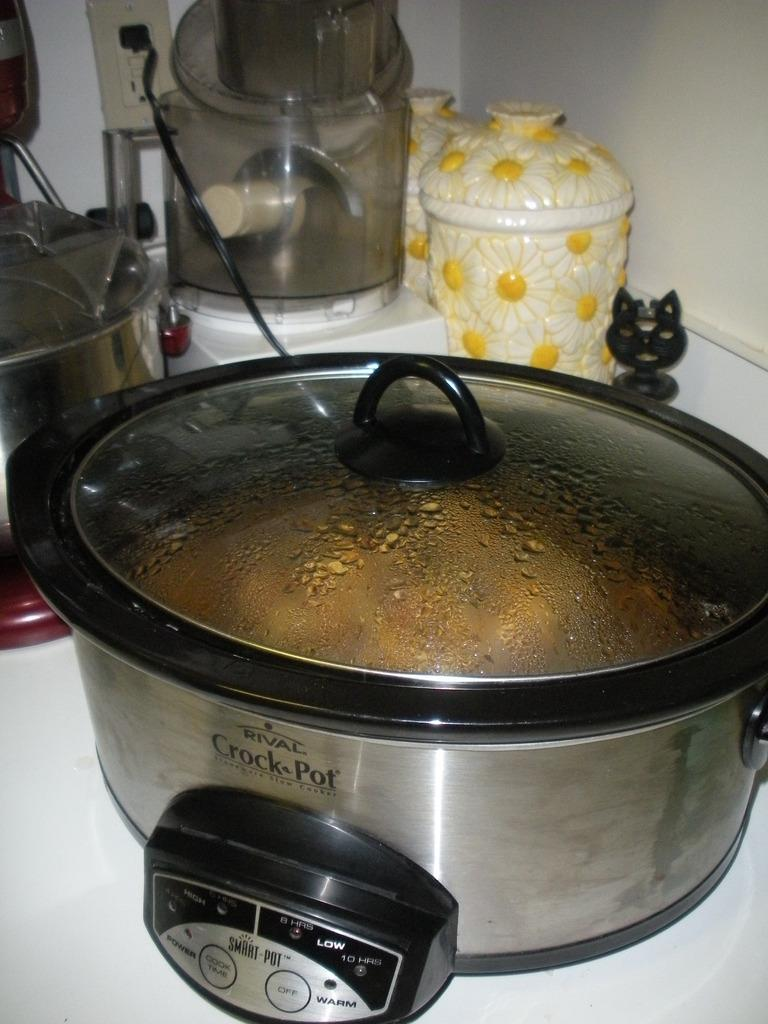What type of objects can be seen in the image? There are utensils and jars in the image. What color is the surface in the image? The surface in the image is white. What color is the wall in the image? The wall in the image is cream-colored. Can you tell me how the utensils are sorting themselves in the image? The utensils are not sorting themselves in the image; they are stationary objects. What type of ocean is visible in the image? There is no ocean present in the image. 